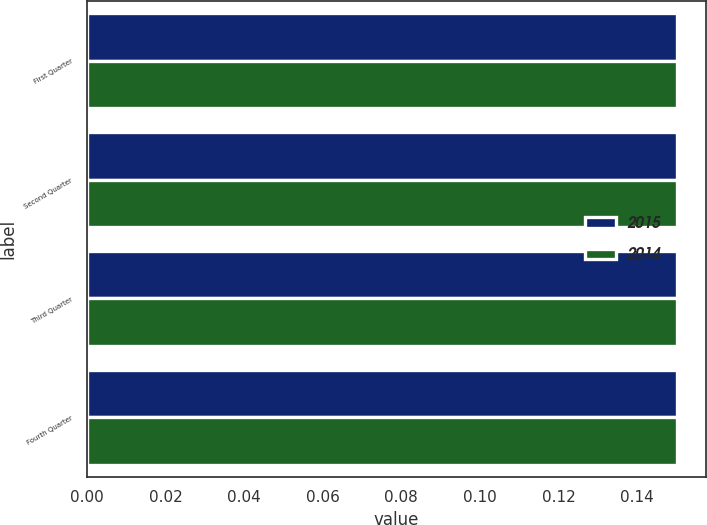<chart> <loc_0><loc_0><loc_500><loc_500><stacked_bar_chart><ecel><fcel>First Quarter<fcel>Second Quarter<fcel>Third Quarter<fcel>Fourth Quarter<nl><fcel>2015<fcel>0.15<fcel>0.15<fcel>0.15<fcel>0.15<nl><fcel>2014<fcel>0.15<fcel>0.15<fcel>0.15<fcel>0.15<nl></chart> 